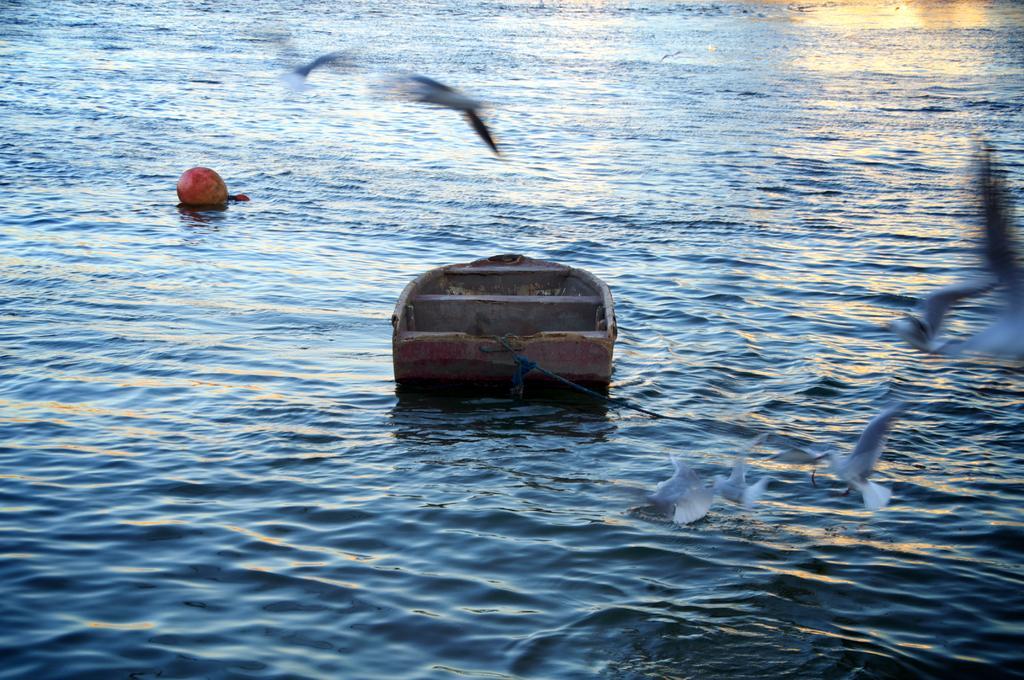Please provide a concise description of this image. In this image, we can see some water with objects floating on it. We can also see some birds flying. 